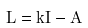Convert formula to latex. <formula><loc_0><loc_0><loc_500><loc_500>L = k I - A</formula> 